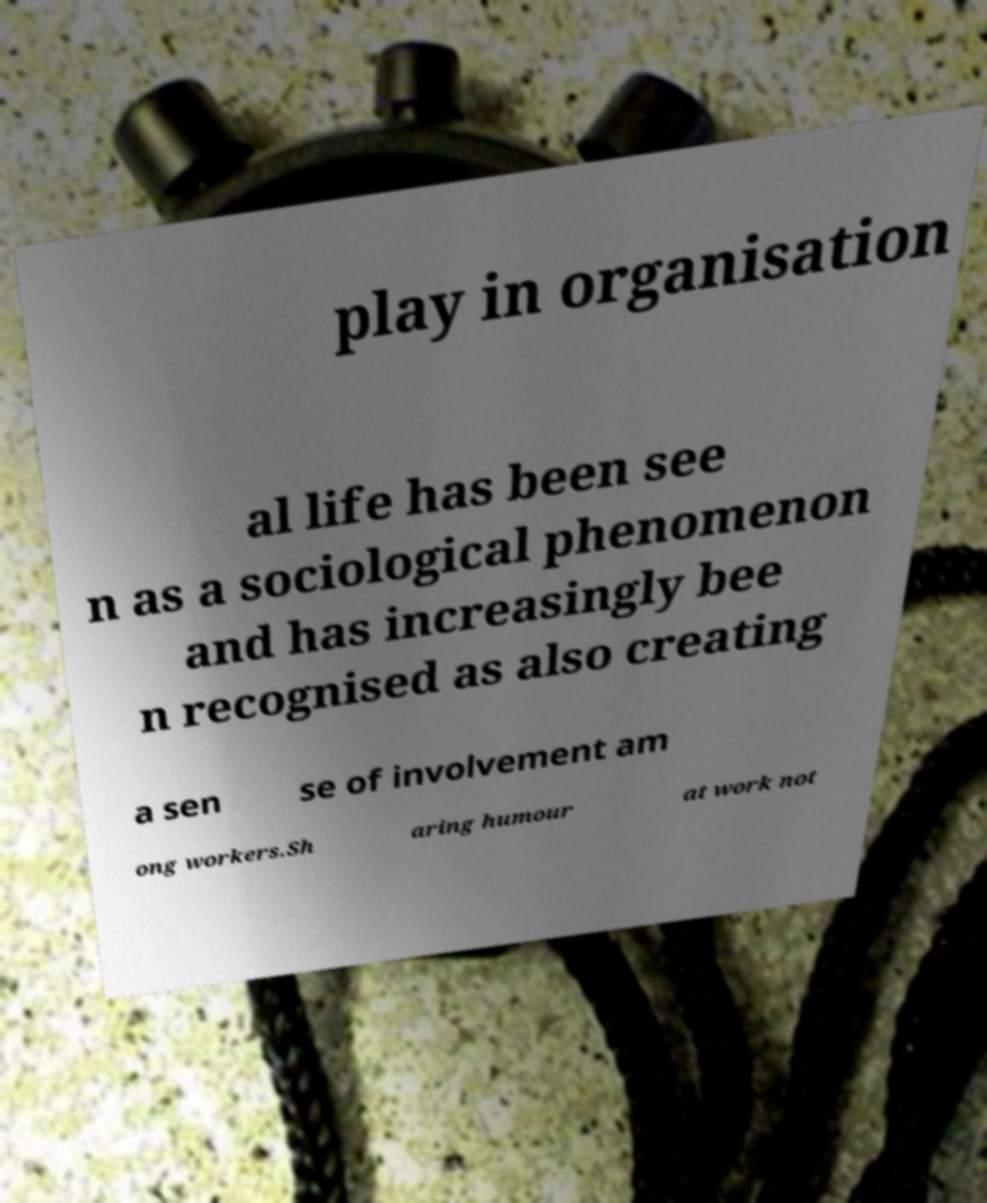There's text embedded in this image that I need extracted. Can you transcribe it verbatim? play in organisation al life has been see n as a sociological phenomenon and has increasingly bee n recognised as also creating a sen se of involvement am ong workers.Sh aring humour at work not 